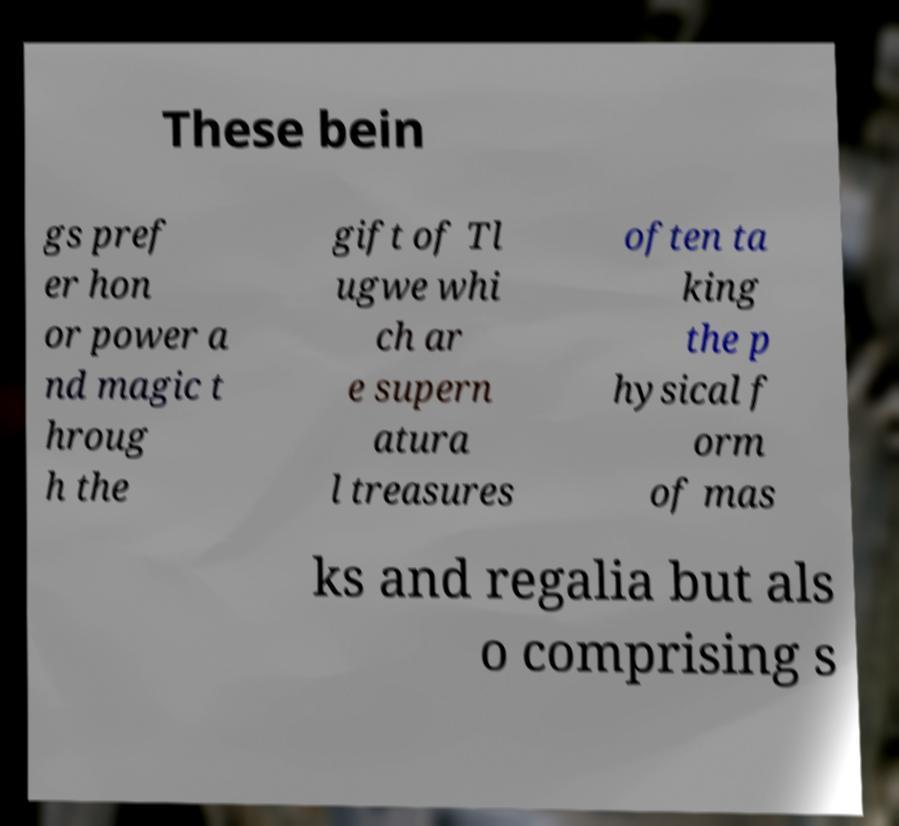For documentation purposes, I need the text within this image transcribed. Could you provide that? These bein gs pref er hon or power a nd magic t hroug h the gift of Tl ugwe whi ch ar e supern atura l treasures often ta king the p hysical f orm of mas ks and regalia but als o comprising s 